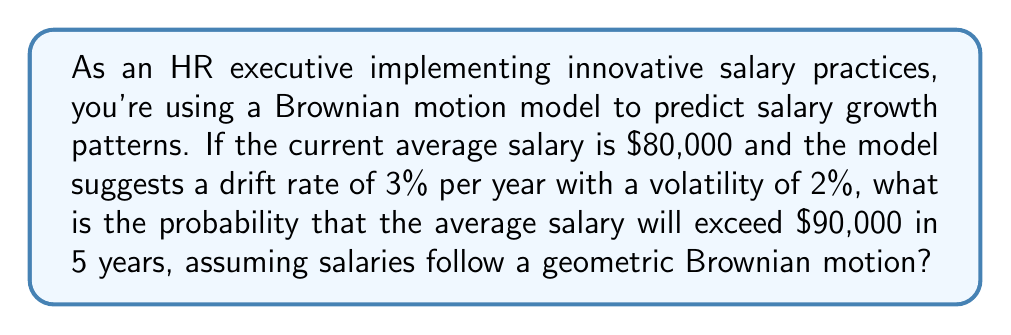Teach me how to tackle this problem. Let's approach this step-by-step using the properties of geometric Brownian motion:

1) The formula for geometric Brownian motion is:

   $$S_t = S_0 \exp\left(\left(\mu - \frac{\sigma^2}{2}\right)t + \sigma W_t\right)$$

   Where $S_t$ is the salary at time $t$, $S_0$ is the initial salary, $\mu$ is the drift rate, $\sigma$ is the volatility, and $W_t$ is a Wiener process.

2) We're given:
   $S_0 = 80,000$
   $\mu = 3\% = 0.03$
   $\sigma = 2\% = 0.02$
   $t = 5$ years

3) For a geometric Brownian motion, $\ln(S_t/S_0)$ is normally distributed with mean $(\mu - \frac{\sigma^2}{2})t$ and variance $\sigma^2t$.

4) We need to find $P(S_5 > 90,000)$, which is equivalent to:

   $$P\left(\ln\left(\frac{S_5}{S_0}\right) > \ln\left(\frac{90,000}{80,000}\right)\right)$$

5) Calculate the mean of $\ln(S_5/S_0)$:
   $$\left(\mu - \frac{\sigma^2}{2}\right)t = \left(0.03 - \frac{0.02^2}{2}\right) \cdot 5 = 0.1490$$

6) Calculate the standard deviation of $\ln(S_5/S_0)$:
   $$\sqrt{\sigma^2t} = \sqrt{0.02^2 \cdot 5} = 0.0447$$

7) Calculate $\ln(90,000/80,000) = \ln(1.125) = 0.1178$

8) The probability can be expressed as:

   $$P\left(Z > \frac{0.1178 - 0.1490}{0.0447}\right) = P(Z > -0.6981)$$

   Where $Z$ is a standard normal random variable.

9) Using a standard normal table or calculator, we find:

   $$P(Z > -0.6981) = 1 - P(Z < -0.6981) = 1 - 0.2426 = 0.7574$$

Therefore, the probability that the average salary will exceed $90,000 in 5 years is approximately 0.7574 or 75.74%.
Answer: 0.7574 